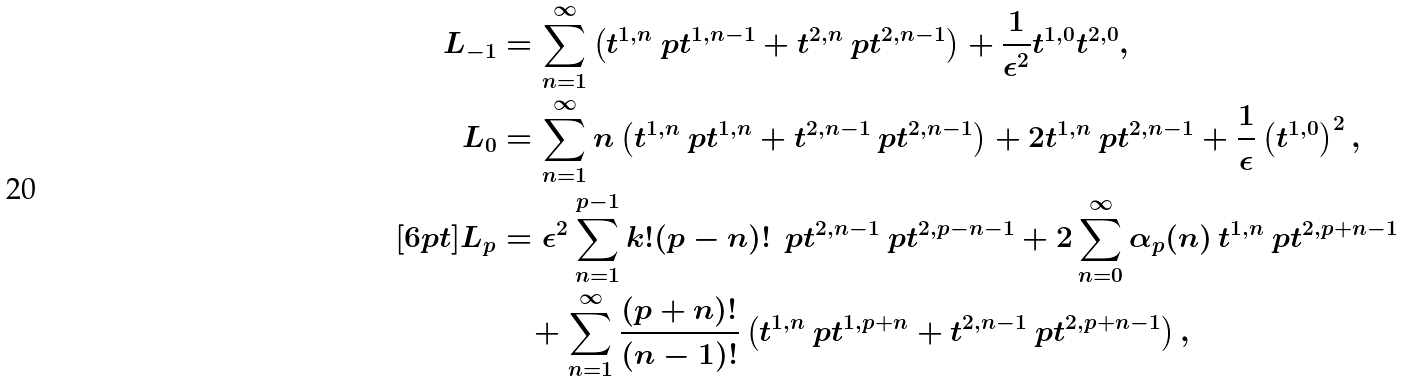<formula> <loc_0><loc_0><loc_500><loc_500>L _ { - 1 } & = \sum _ { n = 1 } ^ { \infty } \left ( t ^ { 1 , n } \ p { t ^ { 1 , n - 1 } } + t ^ { 2 , n } \ p { t ^ { 2 , n - 1 } } \right ) + \frac { 1 } { \epsilon ^ { 2 } } t ^ { 1 , 0 } t ^ { 2 , 0 } , \\ L _ { 0 } & = \sum _ { n = 1 } ^ { \infty } n \left ( t ^ { 1 , n } \ p { t ^ { 1 , n } } + t ^ { 2 , n - 1 } \ p { t ^ { 2 , n - 1 } } \right ) + 2 t ^ { 1 , n } \ p { t ^ { 2 , n - 1 } } + \frac { 1 } { \epsilon } \left ( t ^ { 1 , 0 } \right ) ^ { 2 } , \\ [ 6 p t ] L _ { p } & = \epsilon ^ { 2 } \sum _ { n = 1 } ^ { p - 1 } k ! ( p - n ) ! \, \ p { t ^ { 2 , n - 1 } } \ p { t ^ { 2 , p - n - 1 } } + 2 \sum _ { n = 0 } ^ { \infty } \alpha _ { p } ( n ) \, t ^ { 1 , n } \ p { t ^ { 2 , p + n - 1 } } \\ & \quad + \sum _ { n = 1 } ^ { \infty } \frac { ( p + n ) ! } { ( n - 1 ) ! } \left ( t ^ { 1 , n } \ p { t ^ { 1 , p + n } } + t ^ { 2 , n - 1 } \ p { t ^ { 2 , p + n - 1 } } \right ) ,</formula> 